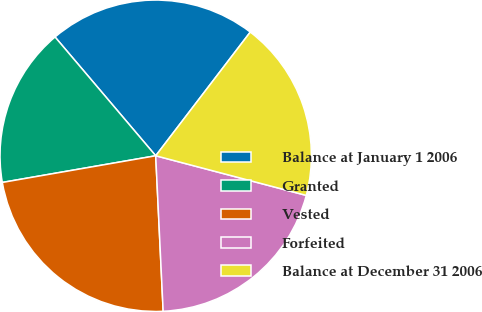Convert chart. <chart><loc_0><loc_0><loc_500><loc_500><pie_chart><fcel>Balance at January 1 2006<fcel>Granted<fcel>Vested<fcel>Forfeited<fcel>Balance at December 31 2006<nl><fcel>21.58%<fcel>16.55%<fcel>23.02%<fcel>20.14%<fcel>18.71%<nl></chart> 